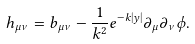Convert formula to latex. <formula><loc_0><loc_0><loc_500><loc_500>h _ { \mu \nu } = b _ { \mu \nu } - \frac { 1 } { k ^ { 2 } } e ^ { - k | y | } \partial _ { \mu } \partial _ { \nu } \phi .</formula> 